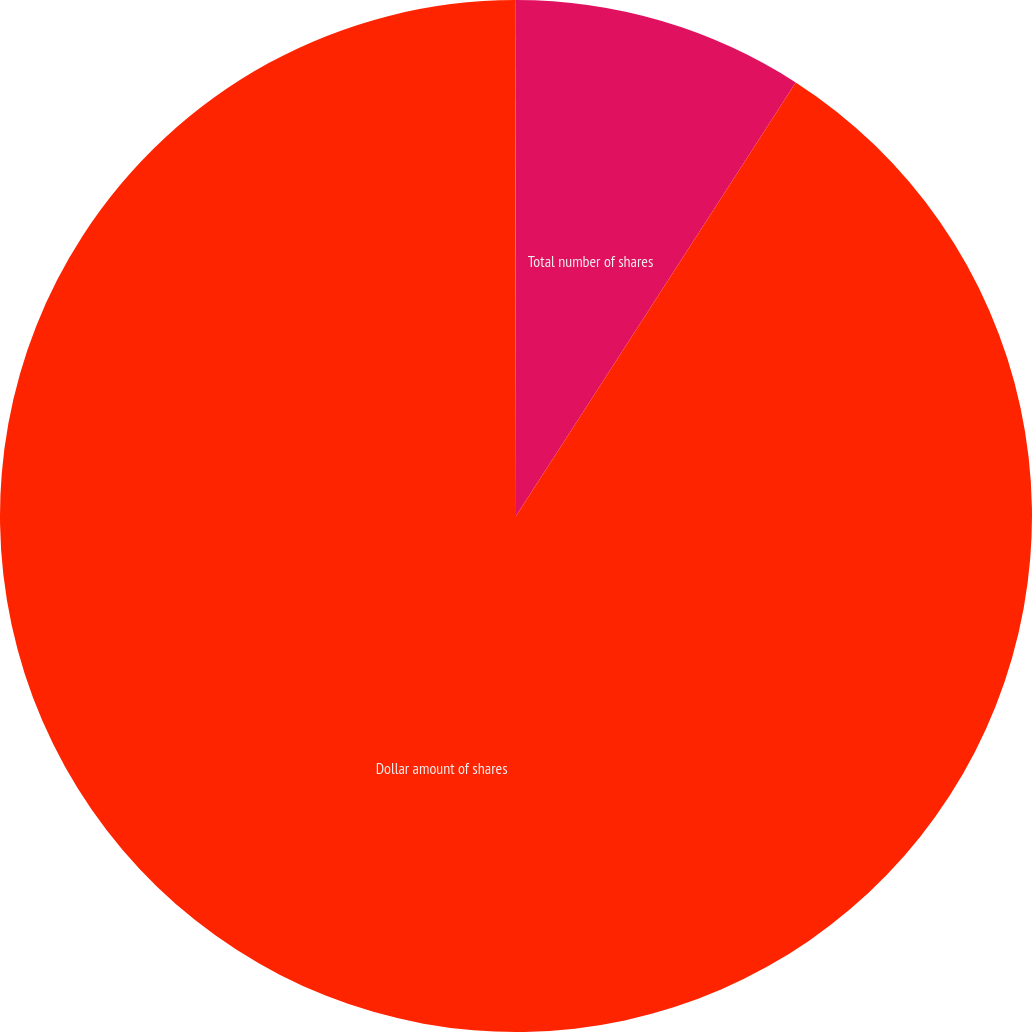<chart> <loc_0><loc_0><loc_500><loc_500><pie_chart><fcel>Total number of shares<fcel>Dollar amount of shares<fcel>Average price paid per share<nl><fcel>9.12%<fcel>90.85%<fcel>0.03%<nl></chart> 